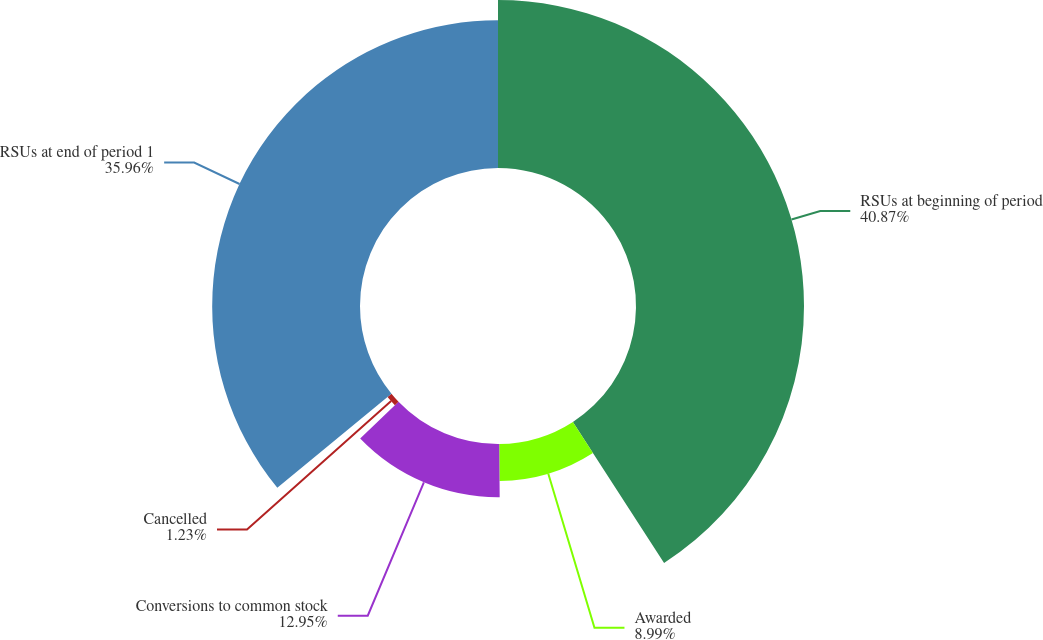Convert chart to OTSL. <chart><loc_0><loc_0><loc_500><loc_500><pie_chart><fcel>RSUs at beginning of period<fcel>Awarded<fcel>Conversions to common stock<fcel>Cancelled<fcel>RSUs at end of period 1<nl><fcel>40.87%<fcel>8.99%<fcel>12.95%<fcel>1.23%<fcel>35.96%<nl></chart> 